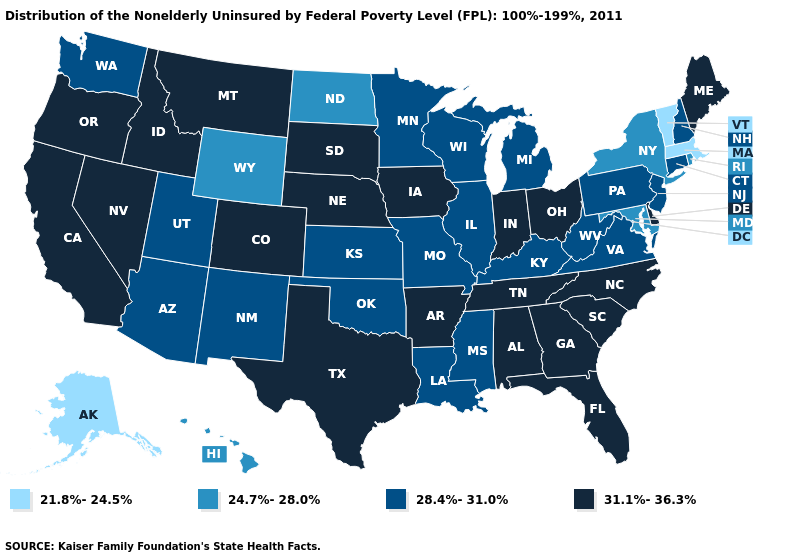Name the states that have a value in the range 31.1%-36.3%?
Concise answer only. Alabama, Arkansas, California, Colorado, Delaware, Florida, Georgia, Idaho, Indiana, Iowa, Maine, Montana, Nebraska, Nevada, North Carolina, Ohio, Oregon, South Carolina, South Dakota, Tennessee, Texas. Name the states that have a value in the range 24.7%-28.0%?
Keep it brief. Hawaii, Maryland, New York, North Dakota, Rhode Island, Wyoming. Among the states that border Idaho , which have the lowest value?
Keep it brief. Wyoming. Name the states that have a value in the range 24.7%-28.0%?
Answer briefly. Hawaii, Maryland, New York, North Dakota, Rhode Island, Wyoming. Name the states that have a value in the range 21.8%-24.5%?
Short answer required. Alaska, Massachusetts, Vermont. Name the states that have a value in the range 28.4%-31.0%?
Keep it brief. Arizona, Connecticut, Illinois, Kansas, Kentucky, Louisiana, Michigan, Minnesota, Mississippi, Missouri, New Hampshire, New Jersey, New Mexico, Oklahoma, Pennsylvania, Utah, Virginia, Washington, West Virginia, Wisconsin. Which states have the lowest value in the South?
Give a very brief answer. Maryland. Does New York have a higher value than Ohio?
Keep it brief. No. Among the states that border Vermont , which have the lowest value?
Write a very short answer. Massachusetts. Does Alaska have the lowest value in the USA?
Answer briefly. Yes. What is the value of Hawaii?
Give a very brief answer. 24.7%-28.0%. Name the states that have a value in the range 28.4%-31.0%?
Write a very short answer. Arizona, Connecticut, Illinois, Kansas, Kentucky, Louisiana, Michigan, Minnesota, Mississippi, Missouri, New Hampshire, New Jersey, New Mexico, Oklahoma, Pennsylvania, Utah, Virginia, Washington, West Virginia, Wisconsin. What is the value of Wisconsin?
Be succinct. 28.4%-31.0%. What is the value of Colorado?
Be succinct. 31.1%-36.3%. Name the states that have a value in the range 28.4%-31.0%?
Short answer required. Arizona, Connecticut, Illinois, Kansas, Kentucky, Louisiana, Michigan, Minnesota, Mississippi, Missouri, New Hampshire, New Jersey, New Mexico, Oklahoma, Pennsylvania, Utah, Virginia, Washington, West Virginia, Wisconsin. 